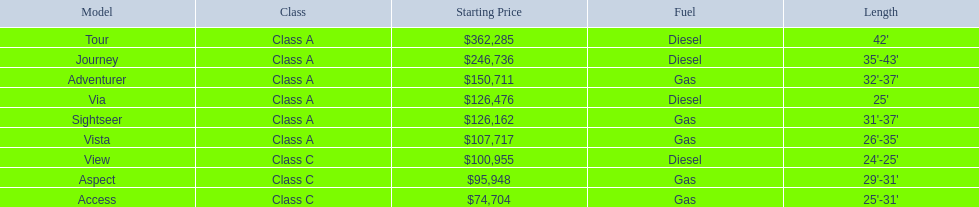What are all the class a models of the winnebago industries? Tour, Journey, Adventurer, Via, Sightseer, Vista. Of those class a models, which has the highest starting price? Tour. 